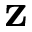<formula> <loc_0><loc_0><loc_500><loc_500>z</formula> 